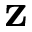<formula> <loc_0><loc_0><loc_500><loc_500>z</formula> 